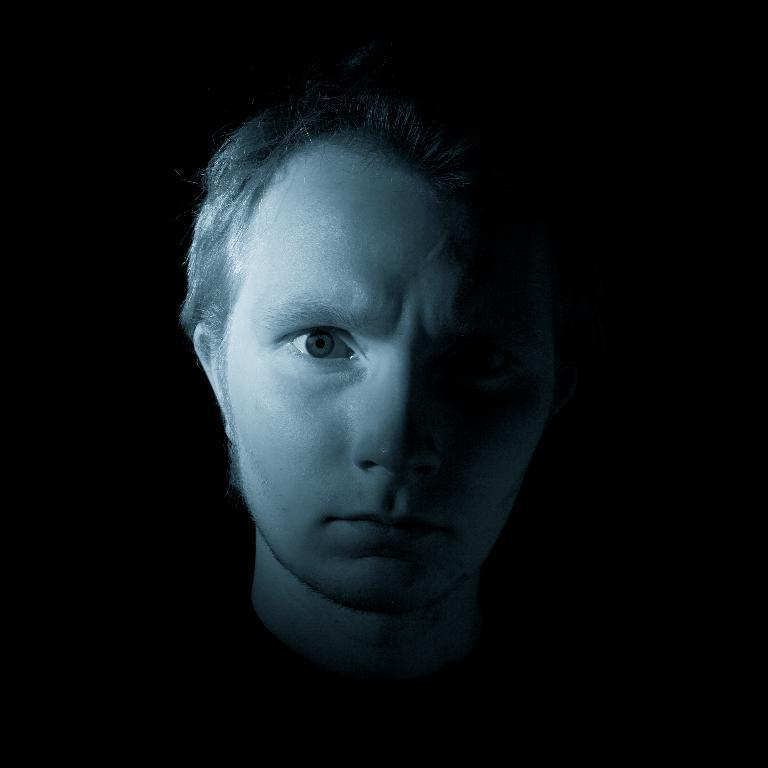Who is the main subject in the image? There is a man in the image. What is the color of the background in the image? The background of the image is black. Can you describe the lighting in the image? There is light on the man's face. What type of honey can be seen dripping from the board in the image? There is no board or honey present in the image. How does the man dispose of the waste in the image? There is no waste present in the image, so it cannot be determined how the man would dispose of it. 